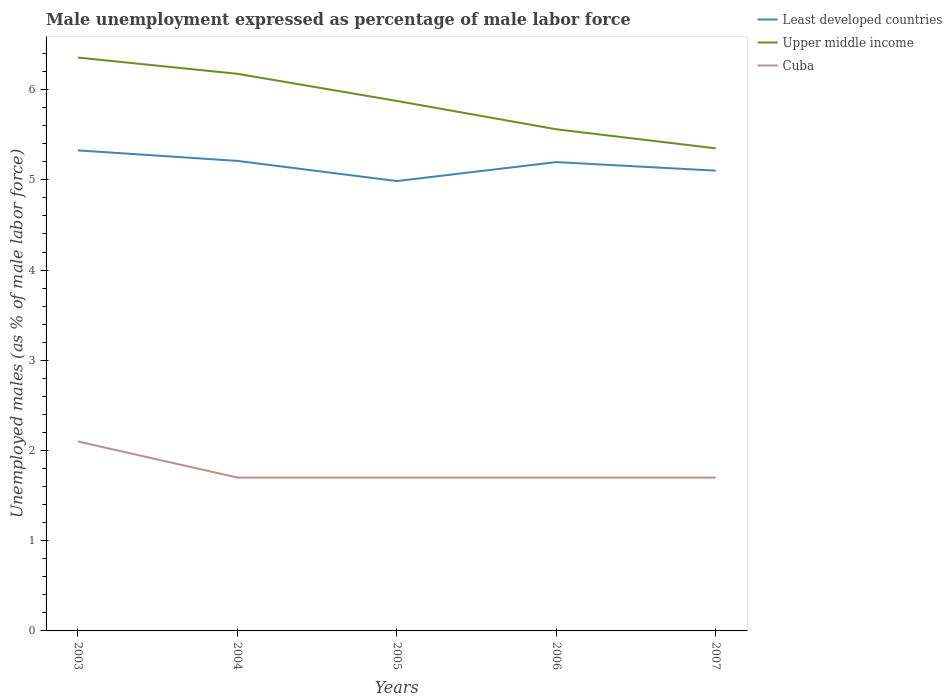Is the number of lines equal to the number of legend labels?
Provide a short and direct response. Yes. Across all years, what is the maximum unemployment in males in in Cuba?
Offer a very short reply. 1.7. What is the total unemployment in males in in Upper middle income in the graph?
Offer a very short reply. 1.01. What is the difference between the highest and the second highest unemployment in males in in Cuba?
Ensure brevity in your answer.  0.4. How many years are there in the graph?
Give a very brief answer. 5. What is the difference between two consecutive major ticks on the Y-axis?
Your answer should be very brief. 1. Are the values on the major ticks of Y-axis written in scientific E-notation?
Keep it short and to the point. No. Does the graph contain any zero values?
Your answer should be very brief. No. Where does the legend appear in the graph?
Offer a terse response. Top right. What is the title of the graph?
Your response must be concise. Male unemployment expressed as percentage of male labor force. What is the label or title of the Y-axis?
Offer a very short reply. Unemployed males (as % of male labor force). What is the Unemployed males (as % of male labor force) in Least developed countries in 2003?
Your response must be concise. 5.33. What is the Unemployed males (as % of male labor force) in Upper middle income in 2003?
Make the answer very short. 6.36. What is the Unemployed males (as % of male labor force) in Cuba in 2003?
Give a very brief answer. 2.1. What is the Unemployed males (as % of male labor force) in Least developed countries in 2004?
Provide a succinct answer. 5.21. What is the Unemployed males (as % of male labor force) of Upper middle income in 2004?
Your response must be concise. 6.18. What is the Unemployed males (as % of male labor force) in Cuba in 2004?
Keep it short and to the point. 1.7. What is the Unemployed males (as % of male labor force) of Least developed countries in 2005?
Your answer should be very brief. 4.99. What is the Unemployed males (as % of male labor force) in Upper middle income in 2005?
Make the answer very short. 5.87. What is the Unemployed males (as % of male labor force) of Cuba in 2005?
Keep it short and to the point. 1.7. What is the Unemployed males (as % of male labor force) in Least developed countries in 2006?
Your answer should be compact. 5.2. What is the Unemployed males (as % of male labor force) in Upper middle income in 2006?
Offer a terse response. 5.56. What is the Unemployed males (as % of male labor force) of Cuba in 2006?
Offer a very short reply. 1.7. What is the Unemployed males (as % of male labor force) of Least developed countries in 2007?
Provide a succinct answer. 5.1. What is the Unemployed males (as % of male labor force) of Upper middle income in 2007?
Your response must be concise. 5.35. What is the Unemployed males (as % of male labor force) of Cuba in 2007?
Give a very brief answer. 1.7. Across all years, what is the maximum Unemployed males (as % of male labor force) of Least developed countries?
Ensure brevity in your answer.  5.33. Across all years, what is the maximum Unemployed males (as % of male labor force) in Upper middle income?
Make the answer very short. 6.36. Across all years, what is the maximum Unemployed males (as % of male labor force) in Cuba?
Your answer should be very brief. 2.1. Across all years, what is the minimum Unemployed males (as % of male labor force) in Least developed countries?
Offer a very short reply. 4.99. Across all years, what is the minimum Unemployed males (as % of male labor force) of Upper middle income?
Ensure brevity in your answer.  5.35. Across all years, what is the minimum Unemployed males (as % of male labor force) of Cuba?
Your answer should be compact. 1.7. What is the total Unemployed males (as % of male labor force) of Least developed countries in the graph?
Provide a succinct answer. 25.82. What is the total Unemployed males (as % of male labor force) of Upper middle income in the graph?
Your response must be concise. 29.32. What is the total Unemployed males (as % of male labor force) in Cuba in the graph?
Keep it short and to the point. 8.9. What is the difference between the Unemployed males (as % of male labor force) of Least developed countries in 2003 and that in 2004?
Give a very brief answer. 0.12. What is the difference between the Unemployed males (as % of male labor force) of Upper middle income in 2003 and that in 2004?
Keep it short and to the point. 0.18. What is the difference between the Unemployed males (as % of male labor force) in Cuba in 2003 and that in 2004?
Ensure brevity in your answer.  0.4. What is the difference between the Unemployed males (as % of male labor force) of Least developed countries in 2003 and that in 2005?
Offer a very short reply. 0.34. What is the difference between the Unemployed males (as % of male labor force) in Upper middle income in 2003 and that in 2005?
Your answer should be very brief. 0.48. What is the difference between the Unemployed males (as % of male labor force) of Least developed countries in 2003 and that in 2006?
Your response must be concise. 0.13. What is the difference between the Unemployed males (as % of male labor force) of Upper middle income in 2003 and that in 2006?
Provide a short and direct response. 0.79. What is the difference between the Unemployed males (as % of male labor force) in Least developed countries in 2003 and that in 2007?
Your answer should be compact. 0.22. What is the difference between the Unemployed males (as % of male labor force) of Upper middle income in 2003 and that in 2007?
Provide a short and direct response. 1.01. What is the difference between the Unemployed males (as % of male labor force) in Least developed countries in 2004 and that in 2005?
Make the answer very short. 0.22. What is the difference between the Unemployed males (as % of male labor force) of Upper middle income in 2004 and that in 2005?
Provide a short and direct response. 0.3. What is the difference between the Unemployed males (as % of male labor force) in Cuba in 2004 and that in 2005?
Provide a short and direct response. 0. What is the difference between the Unemployed males (as % of male labor force) in Least developed countries in 2004 and that in 2006?
Offer a very short reply. 0.01. What is the difference between the Unemployed males (as % of male labor force) of Upper middle income in 2004 and that in 2006?
Your answer should be compact. 0.61. What is the difference between the Unemployed males (as % of male labor force) in Least developed countries in 2004 and that in 2007?
Your answer should be compact. 0.11. What is the difference between the Unemployed males (as % of male labor force) in Upper middle income in 2004 and that in 2007?
Ensure brevity in your answer.  0.83. What is the difference between the Unemployed males (as % of male labor force) of Cuba in 2004 and that in 2007?
Offer a very short reply. 0. What is the difference between the Unemployed males (as % of male labor force) of Least developed countries in 2005 and that in 2006?
Keep it short and to the point. -0.21. What is the difference between the Unemployed males (as % of male labor force) in Upper middle income in 2005 and that in 2006?
Your answer should be compact. 0.31. What is the difference between the Unemployed males (as % of male labor force) of Cuba in 2005 and that in 2006?
Ensure brevity in your answer.  0. What is the difference between the Unemployed males (as % of male labor force) in Least developed countries in 2005 and that in 2007?
Offer a terse response. -0.12. What is the difference between the Unemployed males (as % of male labor force) in Upper middle income in 2005 and that in 2007?
Provide a short and direct response. 0.53. What is the difference between the Unemployed males (as % of male labor force) of Cuba in 2005 and that in 2007?
Your answer should be compact. 0. What is the difference between the Unemployed males (as % of male labor force) of Least developed countries in 2006 and that in 2007?
Offer a very short reply. 0.09. What is the difference between the Unemployed males (as % of male labor force) in Upper middle income in 2006 and that in 2007?
Your response must be concise. 0.21. What is the difference between the Unemployed males (as % of male labor force) in Cuba in 2006 and that in 2007?
Provide a short and direct response. 0. What is the difference between the Unemployed males (as % of male labor force) of Least developed countries in 2003 and the Unemployed males (as % of male labor force) of Upper middle income in 2004?
Offer a very short reply. -0.85. What is the difference between the Unemployed males (as % of male labor force) in Least developed countries in 2003 and the Unemployed males (as % of male labor force) in Cuba in 2004?
Provide a succinct answer. 3.63. What is the difference between the Unemployed males (as % of male labor force) of Upper middle income in 2003 and the Unemployed males (as % of male labor force) of Cuba in 2004?
Provide a short and direct response. 4.66. What is the difference between the Unemployed males (as % of male labor force) in Least developed countries in 2003 and the Unemployed males (as % of male labor force) in Upper middle income in 2005?
Provide a succinct answer. -0.55. What is the difference between the Unemployed males (as % of male labor force) in Least developed countries in 2003 and the Unemployed males (as % of male labor force) in Cuba in 2005?
Provide a short and direct response. 3.63. What is the difference between the Unemployed males (as % of male labor force) in Upper middle income in 2003 and the Unemployed males (as % of male labor force) in Cuba in 2005?
Your response must be concise. 4.66. What is the difference between the Unemployed males (as % of male labor force) in Least developed countries in 2003 and the Unemployed males (as % of male labor force) in Upper middle income in 2006?
Your answer should be very brief. -0.23. What is the difference between the Unemployed males (as % of male labor force) of Least developed countries in 2003 and the Unemployed males (as % of male labor force) of Cuba in 2006?
Offer a terse response. 3.63. What is the difference between the Unemployed males (as % of male labor force) in Upper middle income in 2003 and the Unemployed males (as % of male labor force) in Cuba in 2006?
Give a very brief answer. 4.66. What is the difference between the Unemployed males (as % of male labor force) of Least developed countries in 2003 and the Unemployed males (as % of male labor force) of Upper middle income in 2007?
Make the answer very short. -0.02. What is the difference between the Unemployed males (as % of male labor force) of Least developed countries in 2003 and the Unemployed males (as % of male labor force) of Cuba in 2007?
Offer a very short reply. 3.63. What is the difference between the Unemployed males (as % of male labor force) in Upper middle income in 2003 and the Unemployed males (as % of male labor force) in Cuba in 2007?
Offer a terse response. 4.66. What is the difference between the Unemployed males (as % of male labor force) of Least developed countries in 2004 and the Unemployed males (as % of male labor force) of Upper middle income in 2005?
Your answer should be compact. -0.66. What is the difference between the Unemployed males (as % of male labor force) in Least developed countries in 2004 and the Unemployed males (as % of male labor force) in Cuba in 2005?
Give a very brief answer. 3.51. What is the difference between the Unemployed males (as % of male labor force) of Upper middle income in 2004 and the Unemployed males (as % of male labor force) of Cuba in 2005?
Offer a very short reply. 4.48. What is the difference between the Unemployed males (as % of male labor force) of Least developed countries in 2004 and the Unemployed males (as % of male labor force) of Upper middle income in 2006?
Offer a very short reply. -0.35. What is the difference between the Unemployed males (as % of male labor force) of Least developed countries in 2004 and the Unemployed males (as % of male labor force) of Cuba in 2006?
Make the answer very short. 3.51. What is the difference between the Unemployed males (as % of male labor force) of Upper middle income in 2004 and the Unemployed males (as % of male labor force) of Cuba in 2006?
Keep it short and to the point. 4.48. What is the difference between the Unemployed males (as % of male labor force) of Least developed countries in 2004 and the Unemployed males (as % of male labor force) of Upper middle income in 2007?
Your answer should be compact. -0.14. What is the difference between the Unemployed males (as % of male labor force) in Least developed countries in 2004 and the Unemployed males (as % of male labor force) in Cuba in 2007?
Offer a terse response. 3.51. What is the difference between the Unemployed males (as % of male labor force) of Upper middle income in 2004 and the Unemployed males (as % of male labor force) of Cuba in 2007?
Offer a very short reply. 4.48. What is the difference between the Unemployed males (as % of male labor force) of Least developed countries in 2005 and the Unemployed males (as % of male labor force) of Upper middle income in 2006?
Give a very brief answer. -0.57. What is the difference between the Unemployed males (as % of male labor force) in Least developed countries in 2005 and the Unemployed males (as % of male labor force) in Cuba in 2006?
Ensure brevity in your answer.  3.29. What is the difference between the Unemployed males (as % of male labor force) in Upper middle income in 2005 and the Unemployed males (as % of male labor force) in Cuba in 2006?
Your response must be concise. 4.17. What is the difference between the Unemployed males (as % of male labor force) of Least developed countries in 2005 and the Unemployed males (as % of male labor force) of Upper middle income in 2007?
Offer a terse response. -0.36. What is the difference between the Unemployed males (as % of male labor force) of Least developed countries in 2005 and the Unemployed males (as % of male labor force) of Cuba in 2007?
Ensure brevity in your answer.  3.29. What is the difference between the Unemployed males (as % of male labor force) of Upper middle income in 2005 and the Unemployed males (as % of male labor force) of Cuba in 2007?
Your response must be concise. 4.17. What is the difference between the Unemployed males (as % of male labor force) of Least developed countries in 2006 and the Unemployed males (as % of male labor force) of Upper middle income in 2007?
Keep it short and to the point. -0.15. What is the difference between the Unemployed males (as % of male labor force) in Least developed countries in 2006 and the Unemployed males (as % of male labor force) in Cuba in 2007?
Make the answer very short. 3.5. What is the difference between the Unemployed males (as % of male labor force) in Upper middle income in 2006 and the Unemployed males (as % of male labor force) in Cuba in 2007?
Provide a short and direct response. 3.86. What is the average Unemployed males (as % of male labor force) of Least developed countries per year?
Ensure brevity in your answer.  5.16. What is the average Unemployed males (as % of male labor force) of Upper middle income per year?
Ensure brevity in your answer.  5.86. What is the average Unemployed males (as % of male labor force) of Cuba per year?
Make the answer very short. 1.78. In the year 2003, what is the difference between the Unemployed males (as % of male labor force) of Least developed countries and Unemployed males (as % of male labor force) of Upper middle income?
Your answer should be compact. -1.03. In the year 2003, what is the difference between the Unemployed males (as % of male labor force) of Least developed countries and Unemployed males (as % of male labor force) of Cuba?
Offer a terse response. 3.23. In the year 2003, what is the difference between the Unemployed males (as % of male labor force) of Upper middle income and Unemployed males (as % of male labor force) of Cuba?
Provide a short and direct response. 4.26. In the year 2004, what is the difference between the Unemployed males (as % of male labor force) of Least developed countries and Unemployed males (as % of male labor force) of Upper middle income?
Your response must be concise. -0.97. In the year 2004, what is the difference between the Unemployed males (as % of male labor force) of Least developed countries and Unemployed males (as % of male labor force) of Cuba?
Offer a very short reply. 3.51. In the year 2004, what is the difference between the Unemployed males (as % of male labor force) in Upper middle income and Unemployed males (as % of male labor force) in Cuba?
Provide a succinct answer. 4.48. In the year 2005, what is the difference between the Unemployed males (as % of male labor force) of Least developed countries and Unemployed males (as % of male labor force) of Upper middle income?
Provide a succinct answer. -0.89. In the year 2005, what is the difference between the Unemployed males (as % of male labor force) of Least developed countries and Unemployed males (as % of male labor force) of Cuba?
Provide a succinct answer. 3.29. In the year 2005, what is the difference between the Unemployed males (as % of male labor force) of Upper middle income and Unemployed males (as % of male labor force) of Cuba?
Ensure brevity in your answer.  4.17. In the year 2006, what is the difference between the Unemployed males (as % of male labor force) of Least developed countries and Unemployed males (as % of male labor force) of Upper middle income?
Your answer should be very brief. -0.36. In the year 2006, what is the difference between the Unemployed males (as % of male labor force) of Least developed countries and Unemployed males (as % of male labor force) of Cuba?
Offer a very short reply. 3.5. In the year 2006, what is the difference between the Unemployed males (as % of male labor force) of Upper middle income and Unemployed males (as % of male labor force) of Cuba?
Your answer should be compact. 3.86. In the year 2007, what is the difference between the Unemployed males (as % of male labor force) of Least developed countries and Unemployed males (as % of male labor force) of Upper middle income?
Your answer should be compact. -0.25. In the year 2007, what is the difference between the Unemployed males (as % of male labor force) of Least developed countries and Unemployed males (as % of male labor force) of Cuba?
Your response must be concise. 3.4. In the year 2007, what is the difference between the Unemployed males (as % of male labor force) of Upper middle income and Unemployed males (as % of male labor force) of Cuba?
Your answer should be compact. 3.65. What is the ratio of the Unemployed males (as % of male labor force) of Least developed countries in 2003 to that in 2004?
Your answer should be compact. 1.02. What is the ratio of the Unemployed males (as % of male labor force) of Upper middle income in 2003 to that in 2004?
Provide a short and direct response. 1.03. What is the ratio of the Unemployed males (as % of male labor force) of Cuba in 2003 to that in 2004?
Your response must be concise. 1.24. What is the ratio of the Unemployed males (as % of male labor force) of Least developed countries in 2003 to that in 2005?
Your response must be concise. 1.07. What is the ratio of the Unemployed males (as % of male labor force) of Upper middle income in 2003 to that in 2005?
Offer a very short reply. 1.08. What is the ratio of the Unemployed males (as % of male labor force) of Cuba in 2003 to that in 2005?
Offer a terse response. 1.24. What is the ratio of the Unemployed males (as % of male labor force) in Cuba in 2003 to that in 2006?
Keep it short and to the point. 1.24. What is the ratio of the Unemployed males (as % of male labor force) in Least developed countries in 2003 to that in 2007?
Offer a very short reply. 1.04. What is the ratio of the Unemployed males (as % of male labor force) of Upper middle income in 2003 to that in 2007?
Offer a very short reply. 1.19. What is the ratio of the Unemployed males (as % of male labor force) in Cuba in 2003 to that in 2007?
Offer a very short reply. 1.24. What is the ratio of the Unemployed males (as % of male labor force) in Least developed countries in 2004 to that in 2005?
Make the answer very short. 1.04. What is the ratio of the Unemployed males (as % of male labor force) in Upper middle income in 2004 to that in 2005?
Your answer should be compact. 1.05. What is the ratio of the Unemployed males (as % of male labor force) of Cuba in 2004 to that in 2005?
Offer a very short reply. 1. What is the ratio of the Unemployed males (as % of male labor force) of Least developed countries in 2004 to that in 2006?
Provide a succinct answer. 1. What is the ratio of the Unemployed males (as % of male labor force) of Upper middle income in 2004 to that in 2006?
Make the answer very short. 1.11. What is the ratio of the Unemployed males (as % of male labor force) of Cuba in 2004 to that in 2006?
Provide a short and direct response. 1. What is the ratio of the Unemployed males (as % of male labor force) of Least developed countries in 2004 to that in 2007?
Ensure brevity in your answer.  1.02. What is the ratio of the Unemployed males (as % of male labor force) of Upper middle income in 2004 to that in 2007?
Give a very brief answer. 1.15. What is the ratio of the Unemployed males (as % of male labor force) of Least developed countries in 2005 to that in 2006?
Your response must be concise. 0.96. What is the ratio of the Unemployed males (as % of male labor force) of Upper middle income in 2005 to that in 2006?
Ensure brevity in your answer.  1.06. What is the ratio of the Unemployed males (as % of male labor force) of Cuba in 2005 to that in 2006?
Your answer should be compact. 1. What is the ratio of the Unemployed males (as % of male labor force) in Least developed countries in 2005 to that in 2007?
Offer a terse response. 0.98. What is the ratio of the Unemployed males (as % of male labor force) in Upper middle income in 2005 to that in 2007?
Give a very brief answer. 1.1. What is the ratio of the Unemployed males (as % of male labor force) of Cuba in 2005 to that in 2007?
Provide a succinct answer. 1. What is the ratio of the Unemployed males (as % of male labor force) in Least developed countries in 2006 to that in 2007?
Give a very brief answer. 1.02. What is the ratio of the Unemployed males (as % of male labor force) in Upper middle income in 2006 to that in 2007?
Offer a terse response. 1.04. What is the ratio of the Unemployed males (as % of male labor force) of Cuba in 2006 to that in 2007?
Give a very brief answer. 1. What is the difference between the highest and the second highest Unemployed males (as % of male labor force) of Least developed countries?
Offer a terse response. 0.12. What is the difference between the highest and the second highest Unemployed males (as % of male labor force) in Upper middle income?
Your response must be concise. 0.18. What is the difference between the highest and the second highest Unemployed males (as % of male labor force) in Cuba?
Offer a terse response. 0.4. What is the difference between the highest and the lowest Unemployed males (as % of male labor force) in Least developed countries?
Provide a succinct answer. 0.34. What is the difference between the highest and the lowest Unemployed males (as % of male labor force) of Upper middle income?
Make the answer very short. 1.01. 